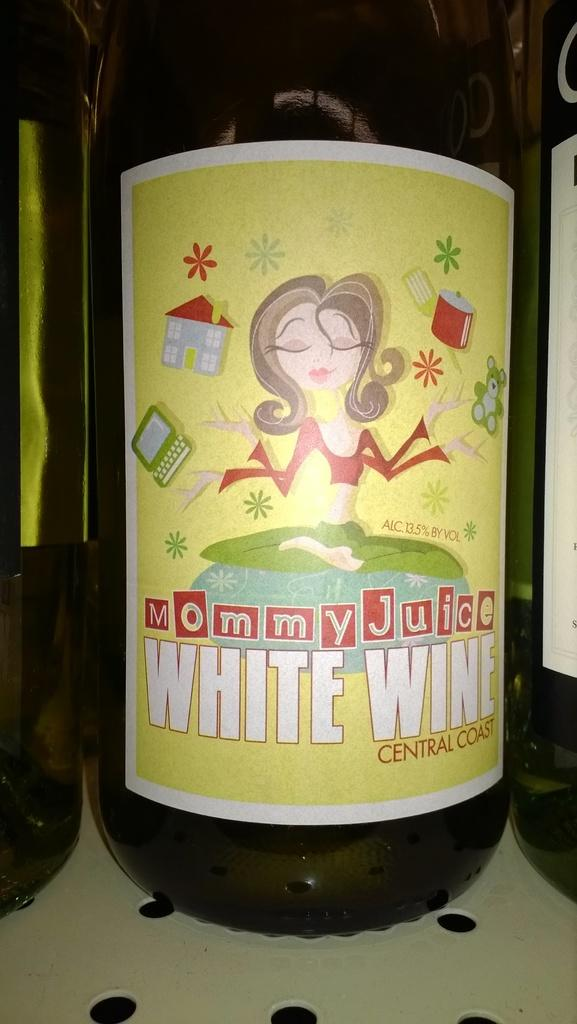<image>
Describe the image concisely. A bottle of white wine says that it is "mommy juice." 